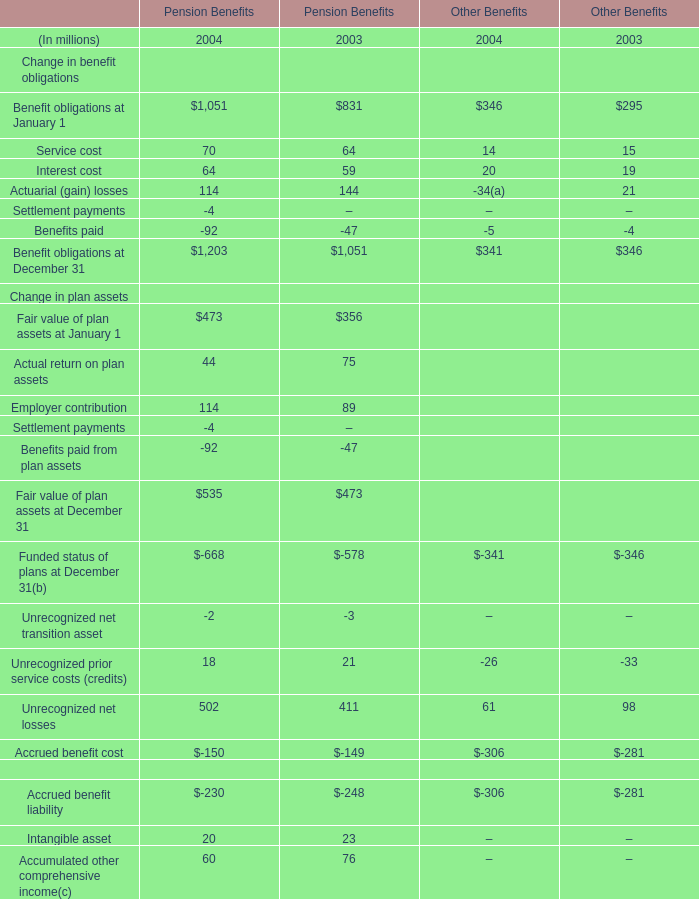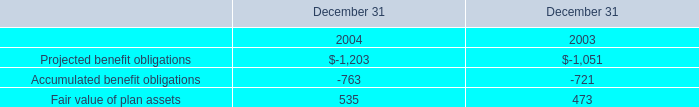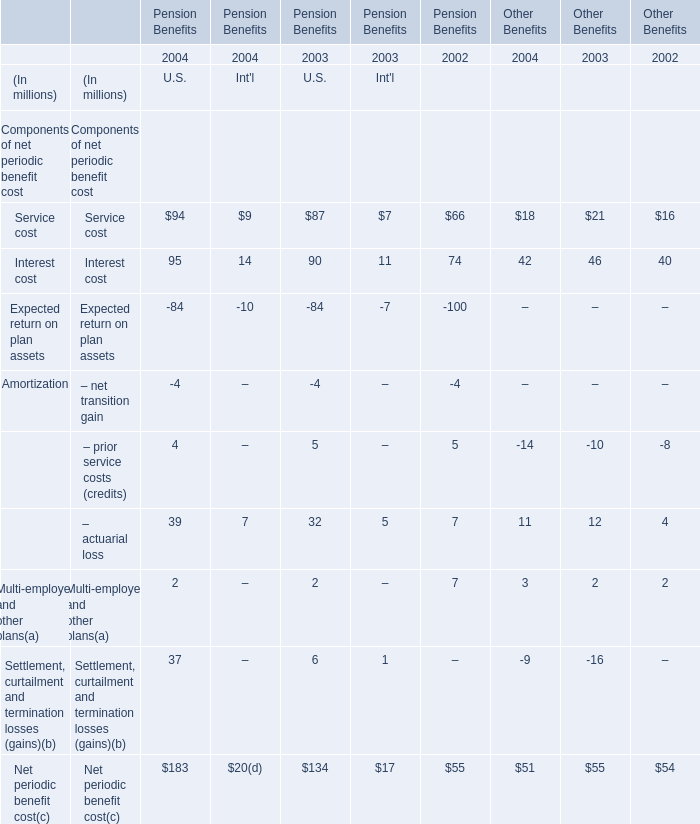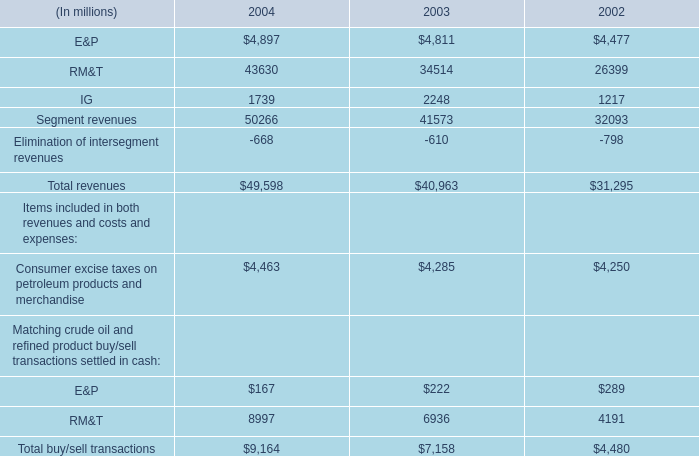At January 1,what year is the value of Benefit obligations for Pension Benefits more? 
Answer: 2004. 